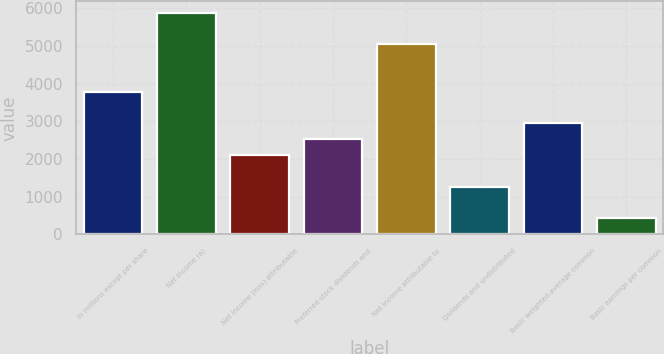Convert chart. <chart><loc_0><loc_0><loc_500><loc_500><bar_chart><fcel>In millions except per share<fcel>Net income (a)<fcel>Net income (loss) attributable<fcel>Preferred stock dividends and<fcel>Net income attributable to<fcel>Dividends and undistributed<fcel>Basic weighted-average common<fcel>Basic earnings per common<nl><fcel>3787.03<fcel>5886.88<fcel>2107.15<fcel>2527.12<fcel>5046.94<fcel>1267.21<fcel>2947.09<fcel>427.27<nl></chart> 